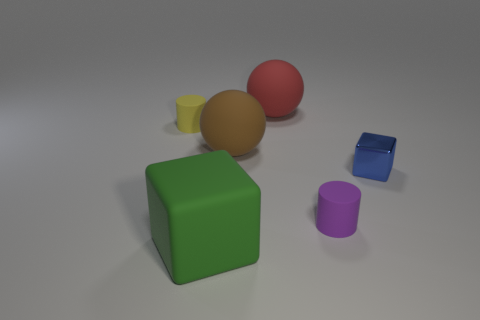Add 3 small yellow matte things. How many objects exist? 9 Subtract 0 gray spheres. How many objects are left? 6 Subtract all big blue rubber balls. Subtract all cubes. How many objects are left? 4 Add 6 large brown spheres. How many large brown spheres are left? 7 Add 6 big red spheres. How many big red spheres exist? 7 